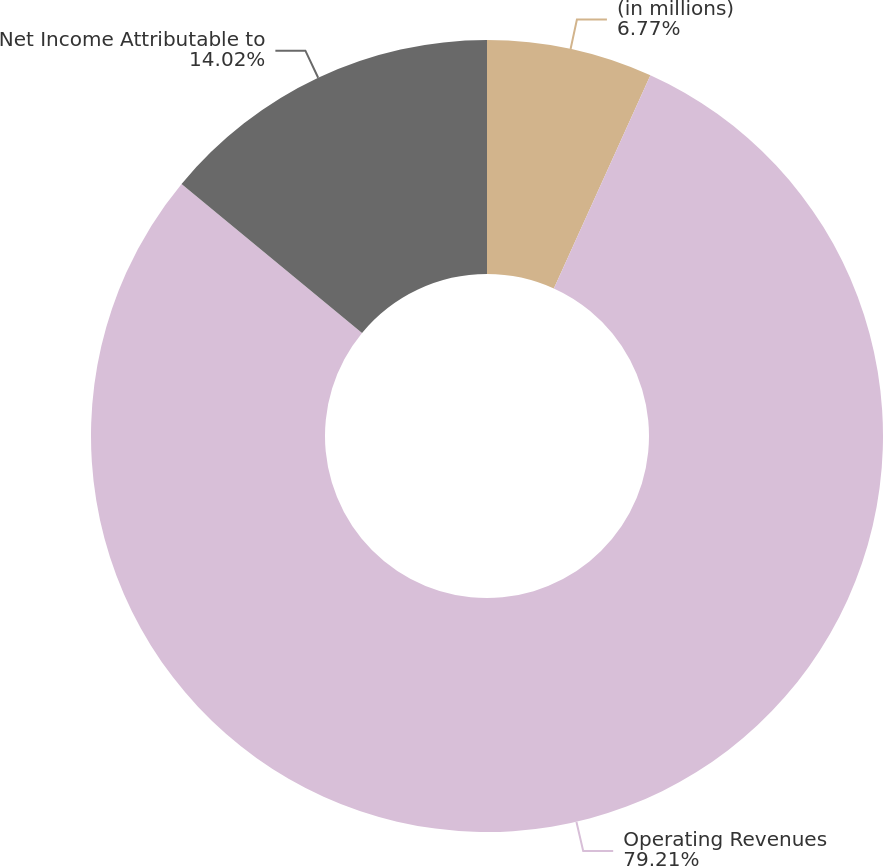Convert chart to OTSL. <chart><loc_0><loc_0><loc_500><loc_500><pie_chart><fcel>(in millions)<fcel>Operating Revenues<fcel>Net Income Attributable to<nl><fcel>6.77%<fcel>79.21%<fcel>14.02%<nl></chart> 